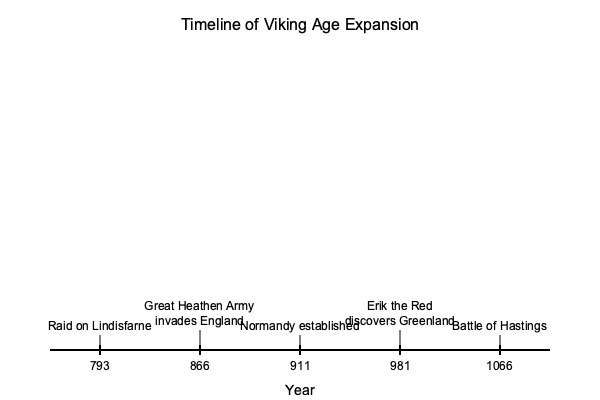Based on the timeline of Viking Age expansion shown in the infographic, which event marked the beginning of the Viking Age, and how many years passed between this event and the establishment of Normandy? To answer this question, we need to follow these steps:

1. Identify the beginning of the Viking Age:
   The raid on Lindisfarne in 793 CE is widely considered the start of the Viking Age.

2. Locate the establishment of Normandy:
   The infographic shows that Normandy was established in 911 CE.

3. Calculate the time difference:
   To find the number of years between these events, we subtract:
   $$ 911 - 793 = 118 $$

This calculation shows that 118 years passed between the raid on Lindisfarne and the establishment of Normandy.

The Viking Age began with the raid on Lindisfarne, showcasing the Vikings' ability to project power beyond Scandinavia. This event set the stage for centuries of Norse expansion, including the eventual settlement of Normandy, which would have a lasting impact on European history.
Answer: Lindisfarne raid (793 CE); 118 years 